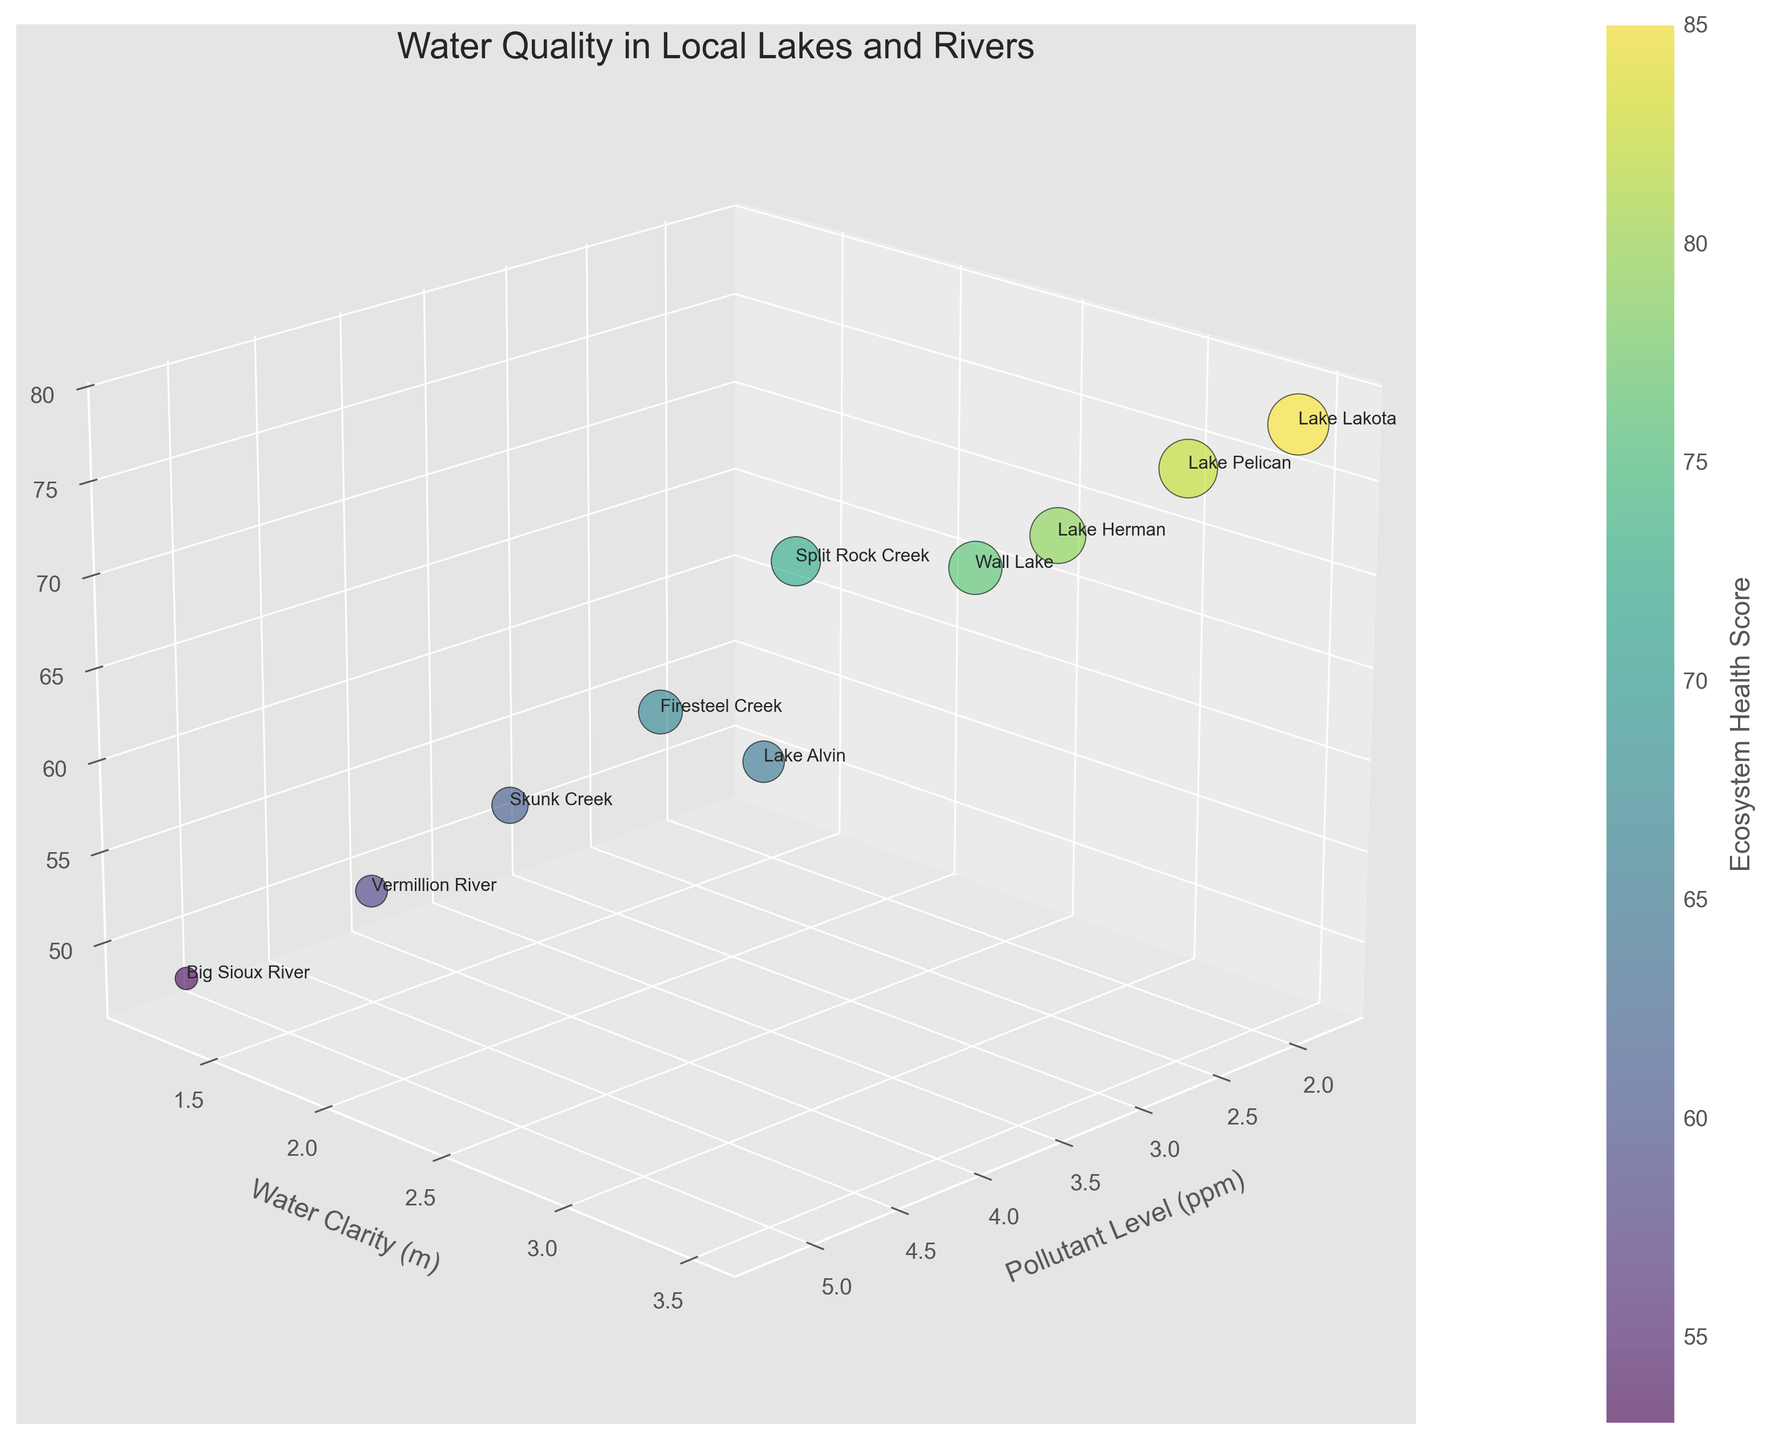what is the title of the figure? The title is usually located at the top center of the figure and briefly describes the content of the chart. In this case, it reads "Water Quality in Local Lakes and Rivers".
Answer: Water Quality in Local Lakes and Rivers Which lake/river has the highest pollutant level? To find this, look at the x-axis labeled "Pollutant Level (ppm)" and identify the data point farthest to the right. It corresponds to "Big Sioux River" with a pollutant level of 5.2 ppm.
Answer: Big Sioux River What is the water clarity for Lake Alvin? To find the water clarity for Lake Alvin, locate its data point on the plot and read the corresponding value on the y-axis labeled "Water Clarity (m)". It shows a water clarity of 2.2 meters.
Answer: 2.2 meters Which lake/river has the lowest ecosystem health score, and what is that score? Locate the data point in the figure with the smallest bubble size and confirm by cross-referencing with colors representing ecosystem health scores. "Big Sioux River" has the lowest ecosystem health score of 53.
Answer: Big Sioux River, 53 What is the average water clarity across all lakes and rivers? To calculate the average water clarity, sum all the values of water clarity: 1.8 + 2.2 + 1.5 + 3.5 + 1.2 + 2.8 + 1.6 + 3.0 + 1.9 + 3.2 = 22.7. Then divide by the number of lakes/rivers (10). Average clarity = 22.7 / 10 = 2.27 meters.
Answer: 2.27 meters Which lake/river has the highest biodiversity index, and what is that index? Identify the data point with the highest z-axis value, which is labeled "Biodiversity Index". This corresponds to "Lake Lakota" with a biodiversity index of 78.
Answer: Lake Lakota, 78 Between Split Rock Creek and Skunk Creek, which one has better water clarity? Compare the y-axis (water clarity) values for both lakes/rivers. Split Rock Creek has a water clarity of 1.8 meters, while Skunk Creek has a clarity of 1.6 meters. Split Rock Creek has better clarity.
Answer: Split Rock Creek Is there a general trend between pollutant levels and ecosystem health scores? Observing the figure, bubbles with higher pollutant levels tend to have lower ecosystem health scores, indicating a possible negative correlation between pollutant levels and ecosystem health.
Answer: Negative correlation Which lake/river appears to have the best overall water quality based on all three metrics (pollutant level, water clarity, biodiversity index)? "Lake Lakota" shows a low pollutant level (1.8 ppm), high water clarity (3.5 meters), and the highest biodiversity index (78), indicating the best overall water quality.
Answer: Lake Lakota 